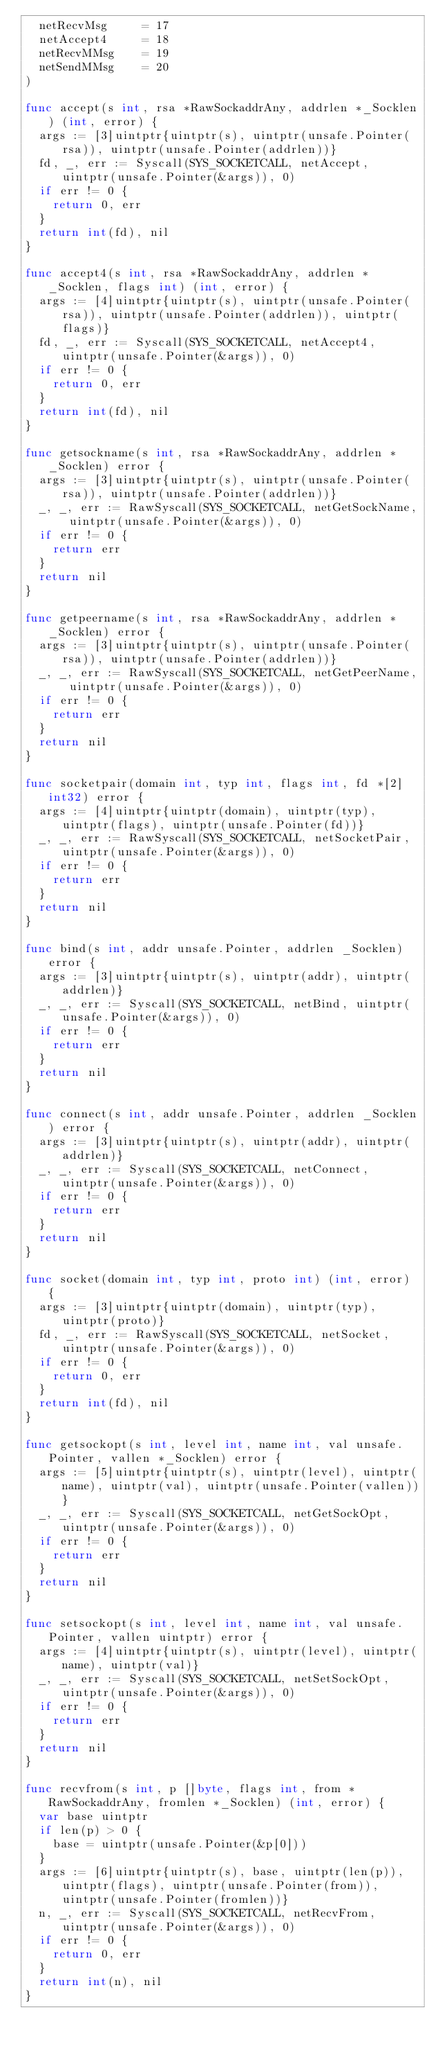Convert code to text. <code><loc_0><loc_0><loc_500><loc_500><_Go_>	netRecvMsg     = 17
	netAccept4     = 18
	netRecvMMsg    = 19
	netSendMMsg    = 20
)

func accept(s int, rsa *RawSockaddrAny, addrlen *_Socklen) (int, error) {
	args := [3]uintptr{uintptr(s), uintptr(unsafe.Pointer(rsa)), uintptr(unsafe.Pointer(addrlen))}
	fd, _, err := Syscall(SYS_SOCKETCALL, netAccept, uintptr(unsafe.Pointer(&args)), 0)
	if err != 0 {
		return 0, err
	}
	return int(fd), nil
}

func accept4(s int, rsa *RawSockaddrAny, addrlen *_Socklen, flags int) (int, error) {
	args := [4]uintptr{uintptr(s), uintptr(unsafe.Pointer(rsa)), uintptr(unsafe.Pointer(addrlen)), uintptr(flags)}
	fd, _, err := Syscall(SYS_SOCKETCALL, netAccept4, uintptr(unsafe.Pointer(&args)), 0)
	if err != 0 {
		return 0, err
	}
	return int(fd), nil
}

func getsockname(s int, rsa *RawSockaddrAny, addrlen *_Socklen) error {
	args := [3]uintptr{uintptr(s), uintptr(unsafe.Pointer(rsa)), uintptr(unsafe.Pointer(addrlen))}
	_, _, err := RawSyscall(SYS_SOCKETCALL, netGetSockName, uintptr(unsafe.Pointer(&args)), 0)
	if err != 0 {
		return err
	}
	return nil
}

func getpeername(s int, rsa *RawSockaddrAny, addrlen *_Socklen) error {
	args := [3]uintptr{uintptr(s), uintptr(unsafe.Pointer(rsa)), uintptr(unsafe.Pointer(addrlen))}
	_, _, err := RawSyscall(SYS_SOCKETCALL, netGetPeerName, uintptr(unsafe.Pointer(&args)), 0)
	if err != 0 {
		return err
	}
	return nil
}

func socketpair(domain int, typ int, flags int, fd *[2]int32) error {
	args := [4]uintptr{uintptr(domain), uintptr(typ), uintptr(flags), uintptr(unsafe.Pointer(fd))}
	_, _, err := RawSyscall(SYS_SOCKETCALL, netSocketPair, uintptr(unsafe.Pointer(&args)), 0)
	if err != 0 {
		return err
	}
	return nil
}

func bind(s int, addr unsafe.Pointer, addrlen _Socklen) error {
	args := [3]uintptr{uintptr(s), uintptr(addr), uintptr(addrlen)}
	_, _, err := Syscall(SYS_SOCKETCALL, netBind, uintptr(unsafe.Pointer(&args)), 0)
	if err != 0 {
		return err
	}
	return nil
}

func connect(s int, addr unsafe.Pointer, addrlen _Socklen) error {
	args := [3]uintptr{uintptr(s), uintptr(addr), uintptr(addrlen)}
	_, _, err := Syscall(SYS_SOCKETCALL, netConnect, uintptr(unsafe.Pointer(&args)), 0)
	if err != 0 {
		return err
	}
	return nil
}

func socket(domain int, typ int, proto int) (int, error) {
	args := [3]uintptr{uintptr(domain), uintptr(typ), uintptr(proto)}
	fd, _, err := RawSyscall(SYS_SOCKETCALL, netSocket, uintptr(unsafe.Pointer(&args)), 0)
	if err != 0 {
		return 0, err
	}
	return int(fd), nil
}

func getsockopt(s int, level int, name int, val unsafe.Pointer, vallen *_Socklen) error {
	args := [5]uintptr{uintptr(s), uintptr(level), uintptr(name), uintptr(val), uintptr(unsafe.Pointer(vallen))}
	_, _, err := Syscall(SYS_SOCKETCALL, netGetSockOpt, uintptr(unsafe.Pointer(&args)), 0)
	if err != 0 {
		return err
	}
	return nil
}

func setsockopt(s int, level int, name int, val unsafe.Pointer, vallen uintptr) error {
	args := [4]uintptr{uintptr(s), uintptr(level), uintptr(name), uintptr(val)}
	_, _, err := Syscall(SYS_SOCKETCALL, netSetSockOpt, uintptr(unsafe.Pointer(&args)), 0)
	if err != 0 {
		return err
	}
	return nil
}

func recvfrom(s int, p []byte, flags int, from *RawSockaddrAny, fromlen *_Socklen) (int, error) {
	var base uintptr
	if len(p) > 0 {
		base = uintptr(unsafe.Pointer(&p[0]))
	}
	args := [6]uintptr{uintptr(s), base, uintptr(len(p)), uintptr(flags), uintptr(unsafe.Pointer(from)), uintptr(unsafe.Pointer(fromlen))}
	n, _, err := Syscall(SYS_SOCKETCALL, netRecvFrom, uintptr(unsafe.Pointer(&args)), 0)
	if err != 0 {
		return 0, err
	}
	return int(n), nil
}
</code> 